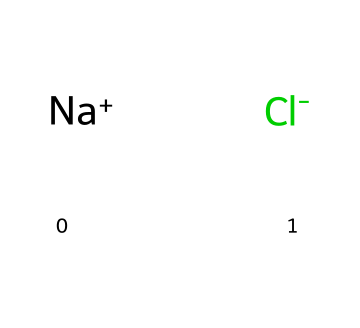What ions are present in this structure? The SMILES representation indicates the presence of sodium and chloride ions, which can be identified by the symbols [Na+] and [Cl-].
Answer: sodium and chloride ions How many ions are present in this compound? In the given chemical structure, there are two distinct ions: one sodium ion and one chloride ion.
Answer: two What type of bond forms between sodium and chloride ions? Sodium ions are positively charged and chloride ions are negatively charged, resulting in an ionic bond formed through electrostatic attraction.
Answer: ionic bond What is the overall charge of the compound represented? The positive charge from the sodium ion balances the negative charge from the chloride ion, resulting in a neutral overall charge for this compound.
Answer: neutral Is this compound soluble in water? Electrolytes, such as sodium chloride, are known to be highly soluble in water due to their ion-dipole interactions with water molecules.
Answer: yes What role do electrolytes like this play in the body? Electrolytes are essential for maintaining proper hydration, nerve function, and muscle contractions, which are vital for overall bodily functions.
Answer: hydration and nerve function 